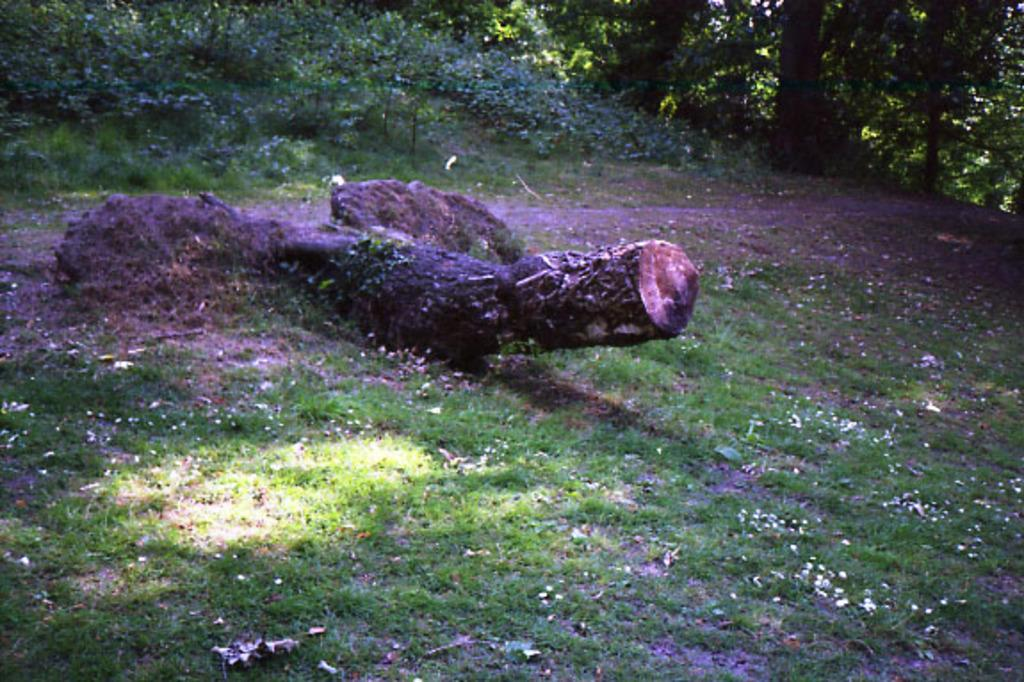What is the main object in the center of the picture? There is a wooden trunk in the center of the picture. What else can be seen in the center of the picture besides the wooden trunk? There is grass and flowers in the center of the picture. What can be seen in the background of the picture? There are plants and trees in the background of the picture. What type of rice is being cooked in the wooden trunk in the image? There is no rice present in the image; it features a wooden trunk, grass, flowers, plants, and trees. 